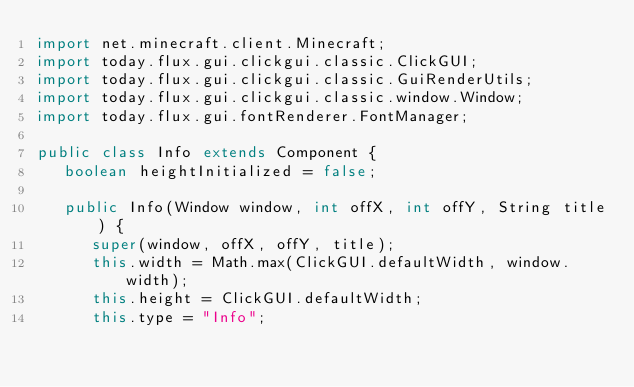Convert code to text. <code><loc_0><loc_0><loc_500><loc_500><_Java_>import net.minecraft.client.Minecraft;
import today.flux.gui.clickgui.classic.ClickGUI;
import today.flux.gui.clickgui.classic.GuiRenderUtils;
import today.flux.gui.clickgui.classic.window.Window;
import today.flux.gui.fontRenderer.FontManager;

public class Info extends Component {
   boolean heightInitialized = false;

   public Info(Window window, int offX, int offY, String title) {
      super(window, offX, offY, title);
      this.width = Math.max(ClickGUI.defaultWidth, window.width);
      this.height = ClickGUI.defaultWidth;
      this.type = "Info";</code> 